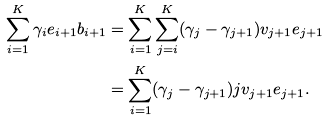Convert formula to latex. <formula><loc_0><loc_0><loc_500><loc_500>\sum _ { i = 1 } ^ { K } \gamma _ { i } e _ { i + 1 } b _ { i + 1 } & = \sum _ { i = 1 } ^ { K } \sum _ { j = i } ^ { K } ( \gamma _ { j } - \gamma _ { j + 1 } ) v _ { j + 1 } e _ { j + 1 } \\ & = \sum _ { i = 1 } ^ { K } ( \gamma _ { j } - \gamma _ { j + 1 } ) j v _ { j + 1 } e _ { j + 1 } .</formula> 